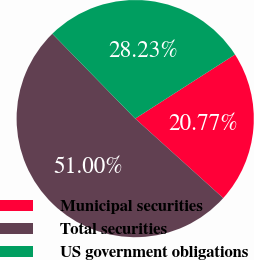Convert chart. <chart><loc_0><loc_0><loc_500><loc_500><pie_chart><fcel>Municipal securities<fcel>Total securities<fcel>US government obligations<nl><fcel>20.77%<fcel>51.0%<fcel>28.23%<nl></chart> 